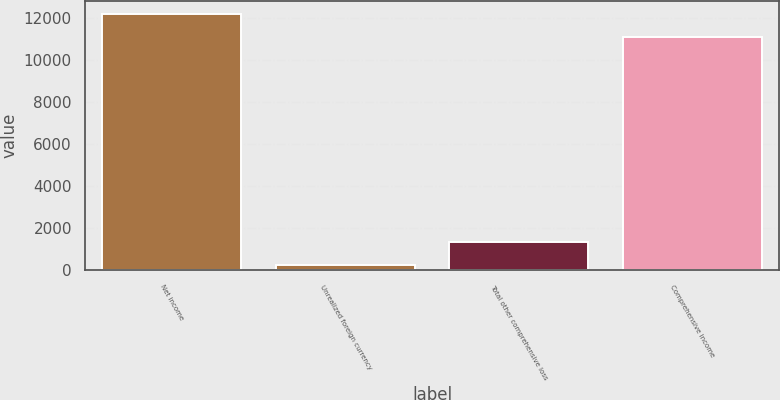Convert chart to OTSL. <chart><loc_0><loc_0><loc_500><loc_500><bar_chart><fcel>Net income<fcel>Unrealized foreign currency<fcel>Total other comprehensive loss<fcel>Comprehensive income<nl><fcel>12201.2<fcel>231<fcel>1340.2<fcel>11092<nl></chart> 